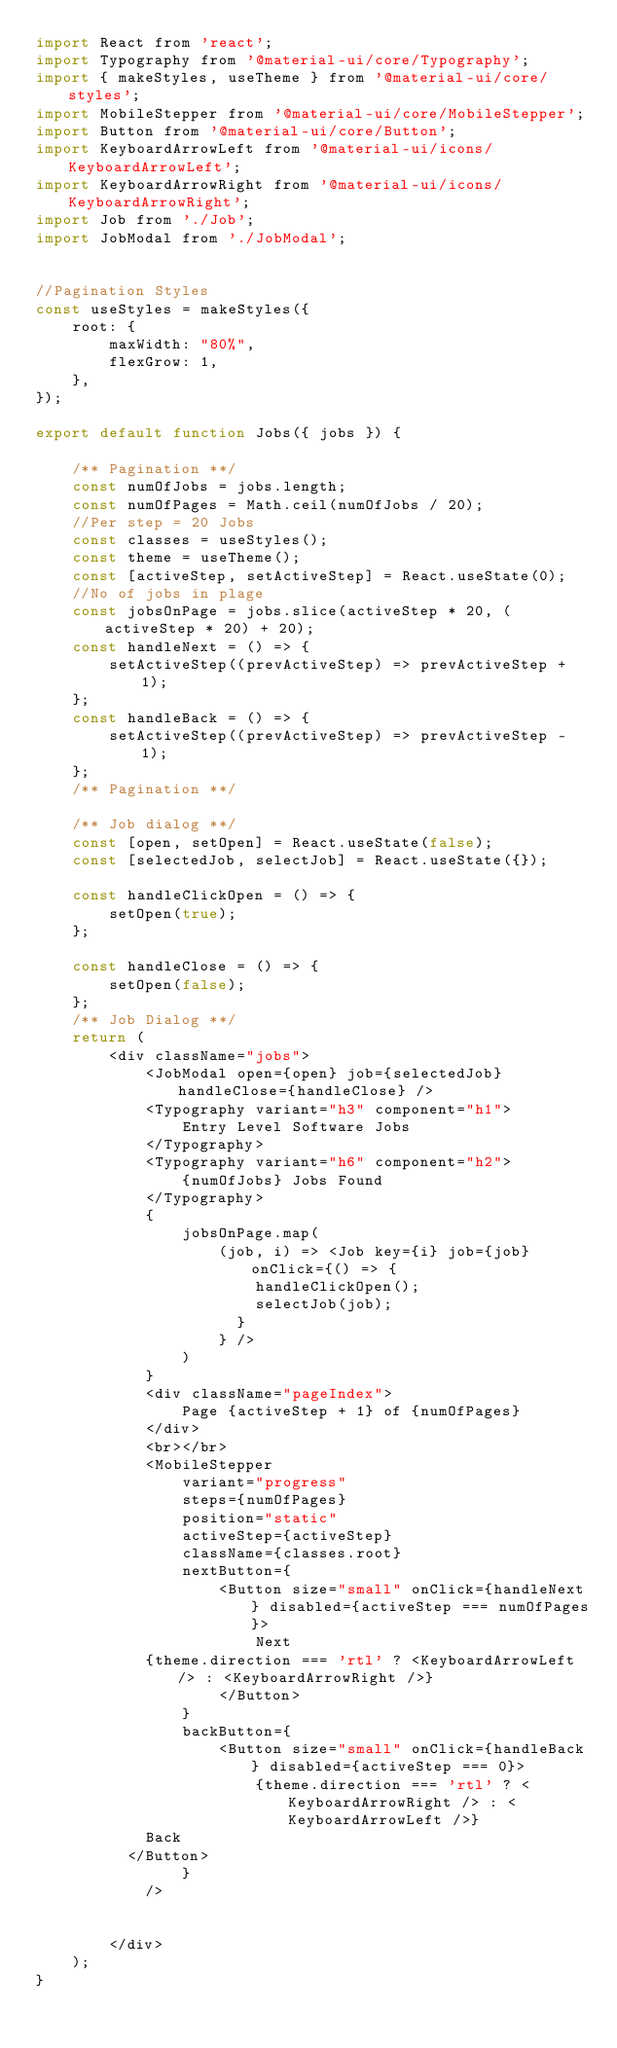<code> <loc_0><loc_0><loc_500><loc_500><_JavaScript_>import React from 'react';
import Typography from '@material-ui/core/Typography';
import { makeStyles, useTheme } from '@material-ui/core/styles';
import MobileStepper from '@material-ui/core/MobileStepper';
import Button from '@material-ui/core/Button';
import KeyboardArrowLeft from '@material-ui/icons/KeyboardArrowLeft';
import KeyboardArrowRight from '@material-ui/icons/KeyboardArrowRight';
import Job from './Job';
import JobModal from './JobModal';


//Pagination Styles
const useStyles = makeStyles({
    root: {
        maxWidth: "80%",
        flexGrow: 1,
    },
});

export default function Jobs({ jobs }) {

    /** Pagination **/
    const numOfJobs = jobs.length;
    const numOfPages = Math.ceil(numOfJobs / 20);
    //Per step = 20 Jobs
    const classes = useStyles();
    const theme = useTheme();
    const [activeStep, setActiveStep] = React.useState(0);
    //No of jobs in plage
    const jobsOnPage = jobs.slice(activeStep * 20, (activeStep * 20) + 20);
    const handleNext = () => {
        setActiveStep((prevActiveStep) => prevActiveStep + 1);
    };
    const handleBack = () => {
        setActiveStep((prevActiveStep) => prevActiveStep - 1);
    };
    /** Pagination **/

    /** Job dialog **/
    const [open, setOpen] = React.useState(false);
    const [selectedJob, selectJob] = React.useState({});

    const handleClickOpen = () => {
        setOpen(true);
    };

    const handleClose = () => {
        setOpen(false);
    };
    /** Job Dialog **/
    return (
        <div className="jobs">
            <JobModal open={open} job={selectedJob} handleClose={handleClose} />
            <Typography variant="h3" component="h1">
                Entry Level Software Jobs
            </Typography>
            <Typography variant="h6" component="h2">
                {numOfJobs} Jobs Found
            </Typography>
            {
                jobsOnPage.map(
                    (job, i) => <Job key={i} job={job} onClick={() => {
                        handleClickOpen();
                        selectJob(job);
                      }
                    } />
                )
            }
            <div className="pageIndex">
                Page {activeStep + 1} of {numOfPages}
            </div>
            <br></br>
            <MobileStepper
                variant="progress"
                steps={numOfPages}
                position="static"
                activeStep={activeStep}
                className={classes.root}
                nextButton={
                    <Button size="small" onClick={handleNext} disabled={activeStep === numOfPages}>
                        Next
            {theme.direction === 'rtl' ? <KeyboardArrowLeft /> : <KeyboardArrowRight />}
                    </Button>
                }
                backButton={
                    <Button size="small" onClick={handleBack} disabled={activeStep === 0}>
                        {theme.direction === 'rtl' ? <KeyboardArrowRight /> : <KeyboardArrowLeft />}
            Back
          </Button>
                }
            />


        </div>
    );
}</code> 